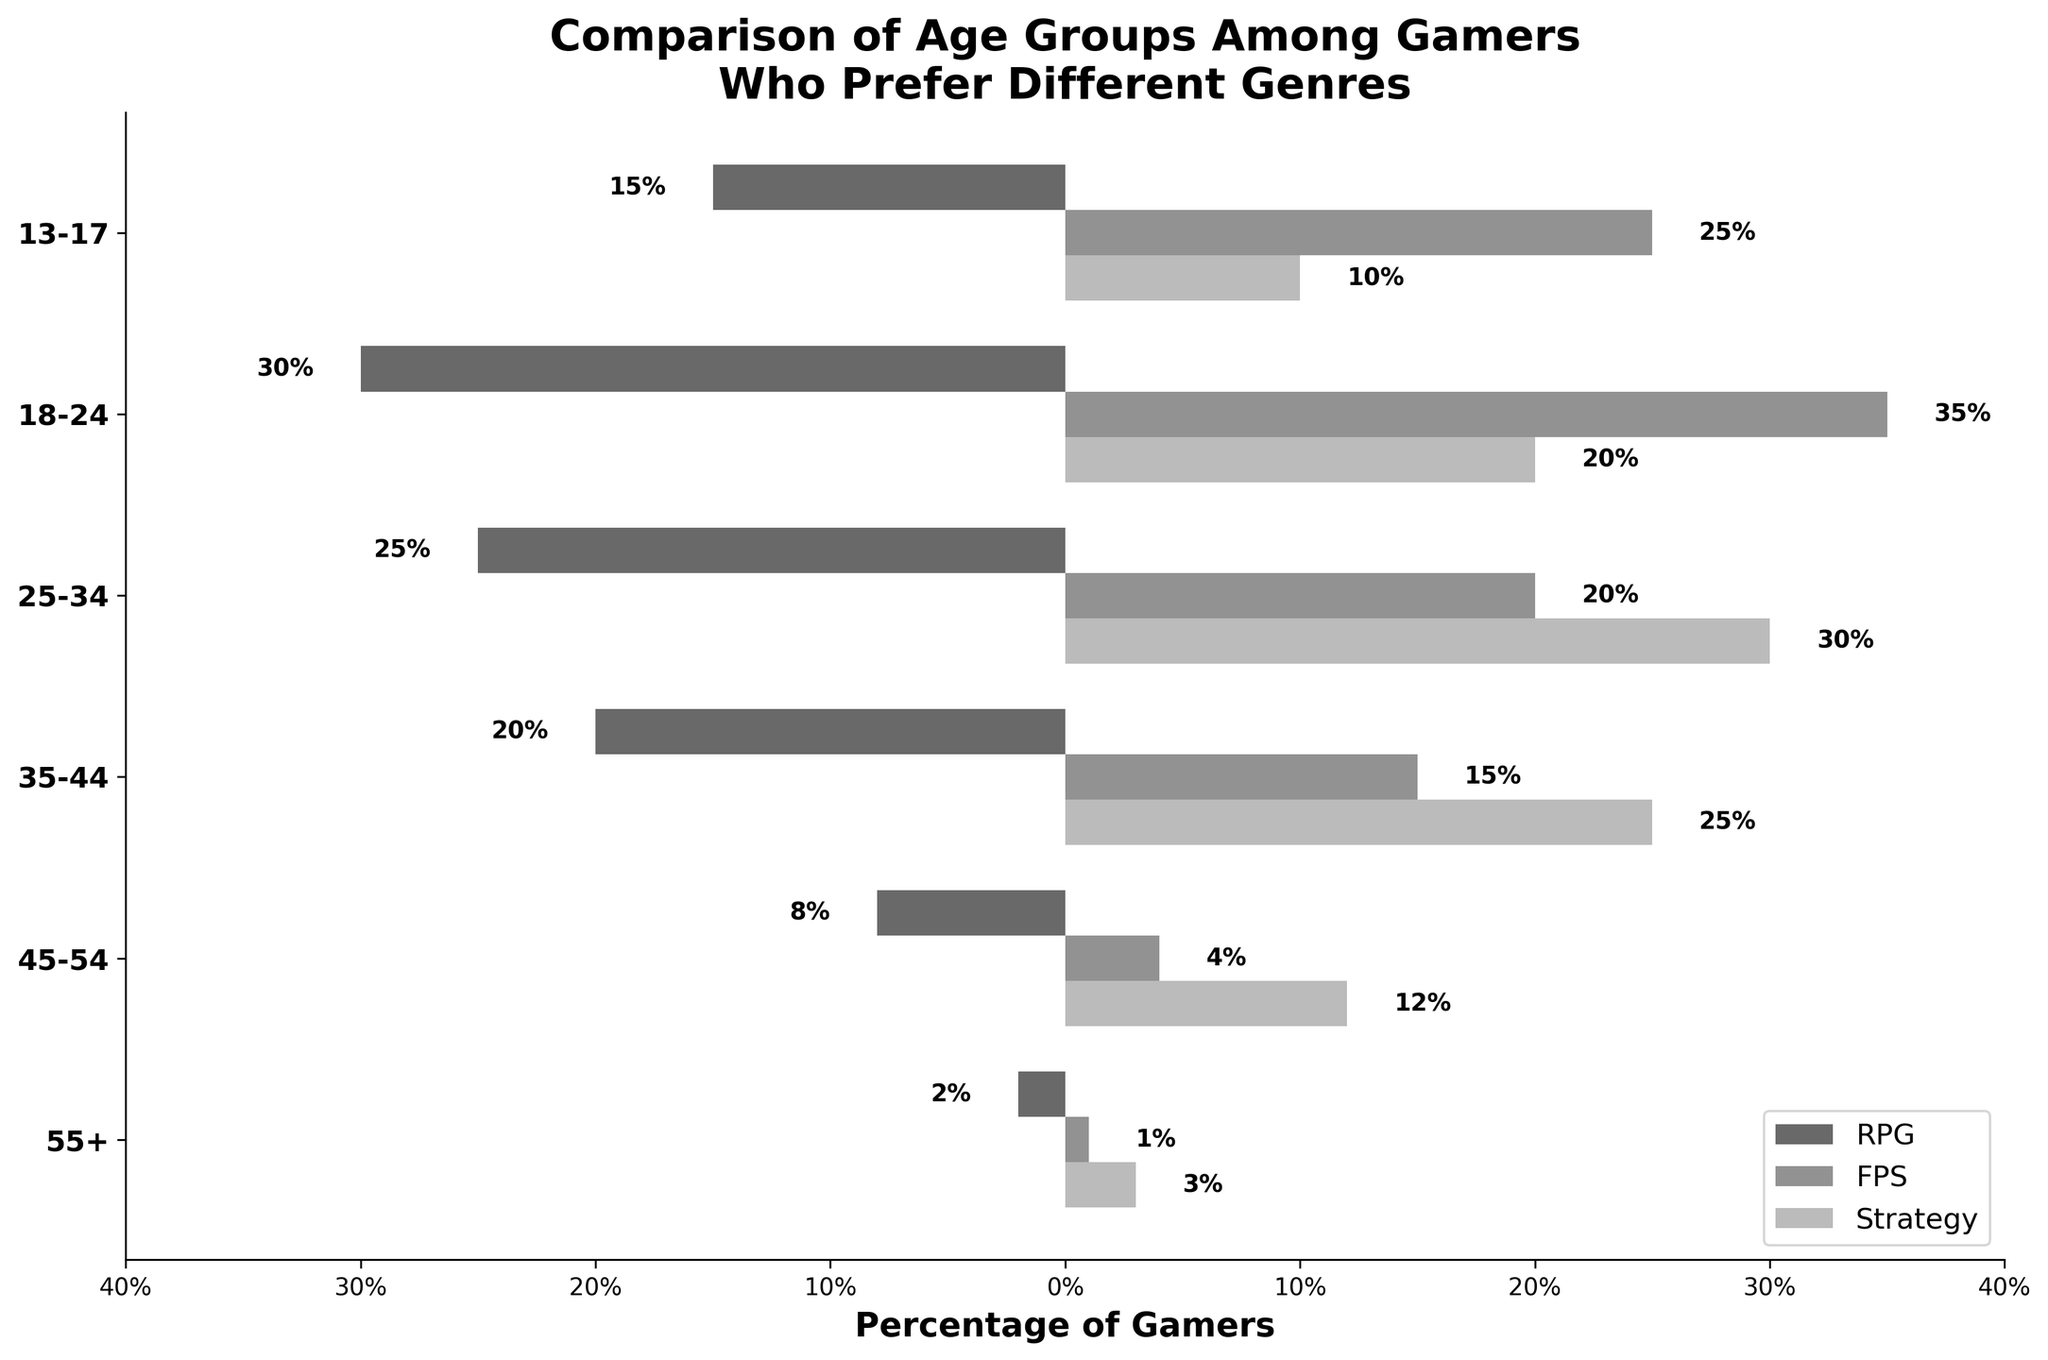What is the title of the figure? The title is located at the top of the figure. It reads, "Comparison of Age Groups Among Gamers Who Prefer Different Genres."
Answer: Comparison of Age Groups Among Gamers Who Prefer Different Genres What percentage of RPG gamers are aged 18-24? On the left side of the figure, refer to the 18-24 age group. The corresponding RPG bar extends to 30%, indicated by the text label beside it.
Answer: 30% Which genre has the highest percentage of gamers in the 13-17 age group? Compare the bars for each genre in the 13-17 age group. The FPS bar extends furthest to the right at 25%, compared to 15% for RPG and 10% for strategy.
Answer: FPS How does the percentage of gamers aged 35-44 who prefer strategy compare to those who prefer RPG? For the 35-44 age group, the strategy bar extends to 25%, and the RPG bar extends to 20% on the left side. Strategy has a higher percentage by 5%.
Answer: Strategy has 5% more What is the combined percentage of FPS gamers in the age groups 45-54 and 55+? In the 45-54 age group, the FPS percentage is 4%. In the 55+ age group, it’s 1%. Adding these gives 4% + 1% = 5%.
Answer: 5% Which age group has the lowest percentage of gamers who prefer any genre? Examine the bars for each genre across all age groups. The 55+ age group has the lowest total percentages with RPG at 2%, FPS at 1%, and strategy at 3%.
Answer: 55+ In which age group do RPG and strategy gamers have the same percentage? Compare RPG and strategy bars across all age groups. In the 25-34 age group, both genres have a percentage of 25%.
Answer: 25-34 What is the total percentage of gamers aged 13-17 who prefer RPG and strategy combined? For the 13-17 age group, RPG is 15% and strategy is 10%. Adding these gives 15% + 10% = 25%.
Answer: 25% What is the difference in percentage between FPS gamers aged 18-24 and RPG gamers aged 25-34? The percentage of FPS gamers aged 18-24 is 35%. The percentage of RPG gamers aged 25-34 is 25%. The difference is 35% - 25% = 10%.
Answer: 10% How does the percentage of strategy gamers aged 45-54 compare to those aged 18-24? The strategy bar for the 45-54 age group extends to 12%. For the 18-24 age group, it extends to 20%. Subtracting, 20% - 12% = 8%.
Answer: 8% fewer 